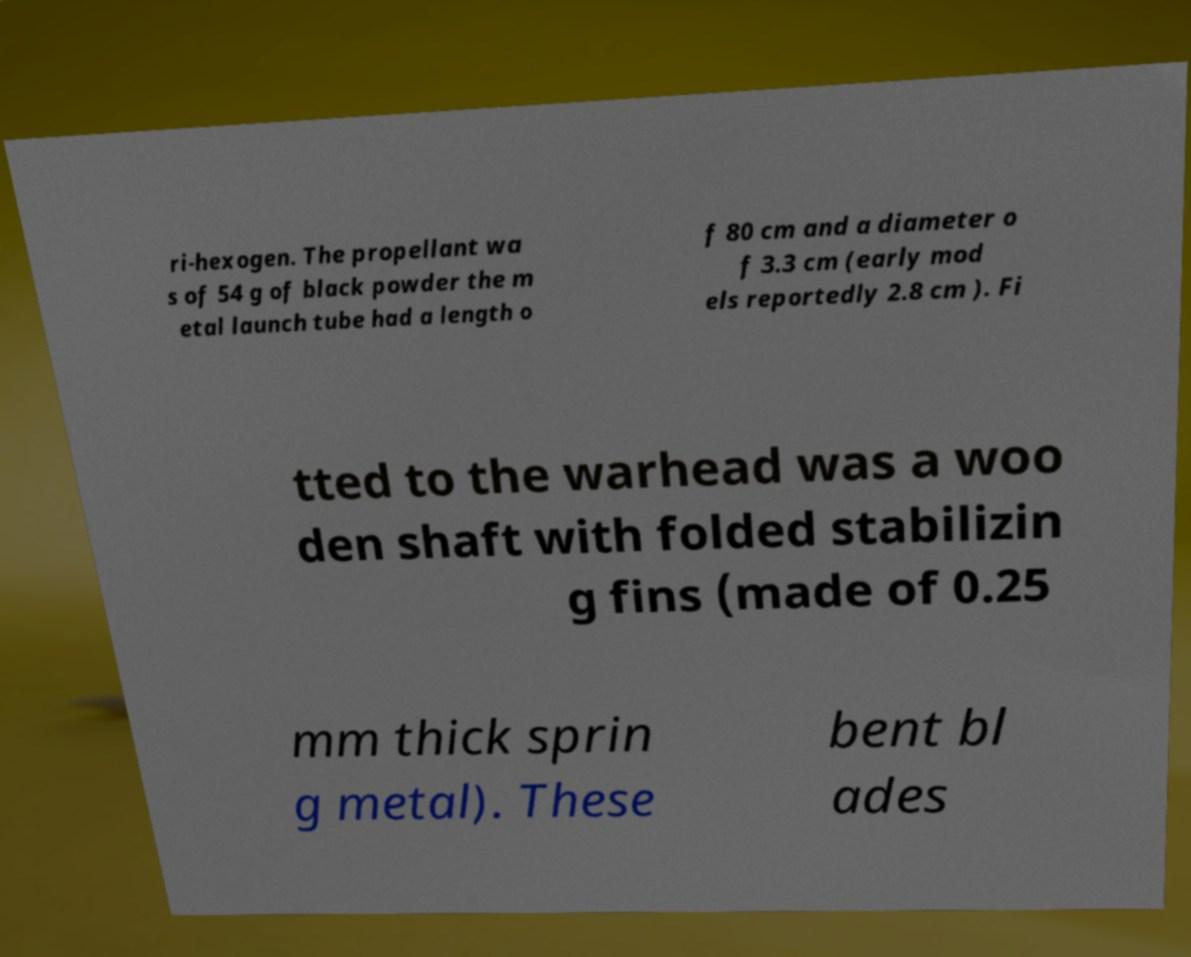Please read and relay the text visible in this image. What does it say? ri-hexogen. The propellant wa s of 54 g of black powder the m etal launch tube had a length o f 80 cm and a diameter o f 3.3 cm (early mod els reportedly 2.8 cm ). Fi tted to the warhead was a woo den shaft with folded stabilizin g fins (made of 0.25 mm thick sprin g metal). These bent bl ades 